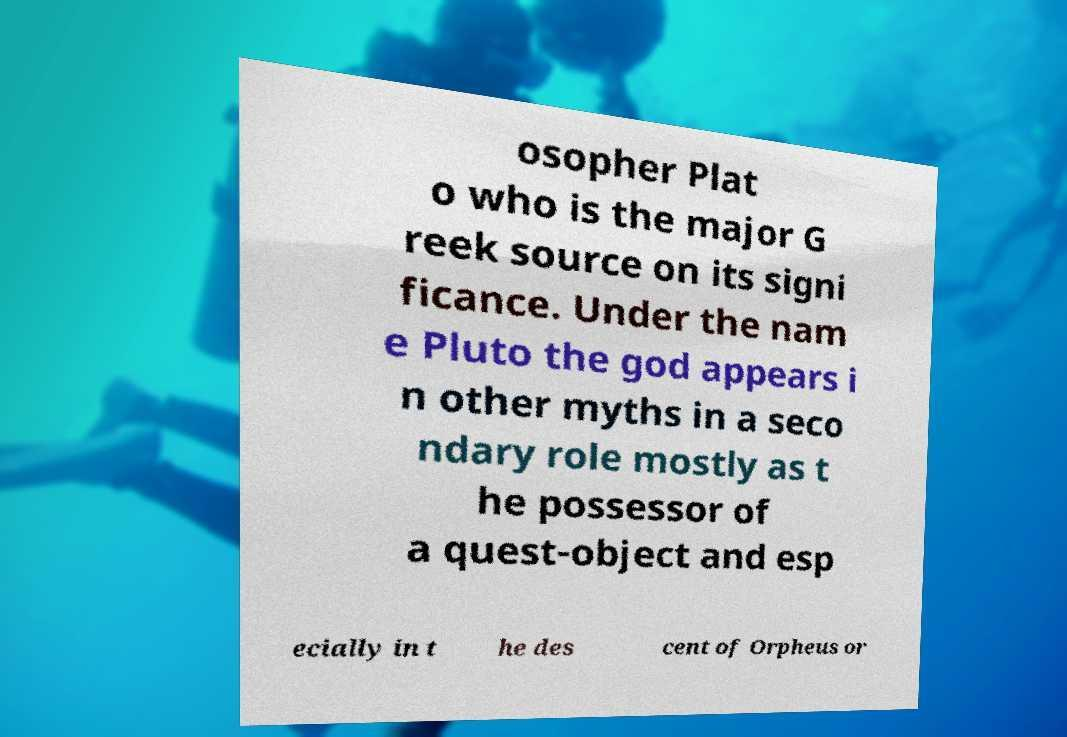What messages or text are displayed in this image? I need them in a readable, typed format. osopher Plat o who is the major G reek source on its signi ficance. Under the nam e Pluto the god appears i n other myths in a seco ndary role mostly as t he possessor of a quest-object and esp ecially in t he des cent of Orpheus or 